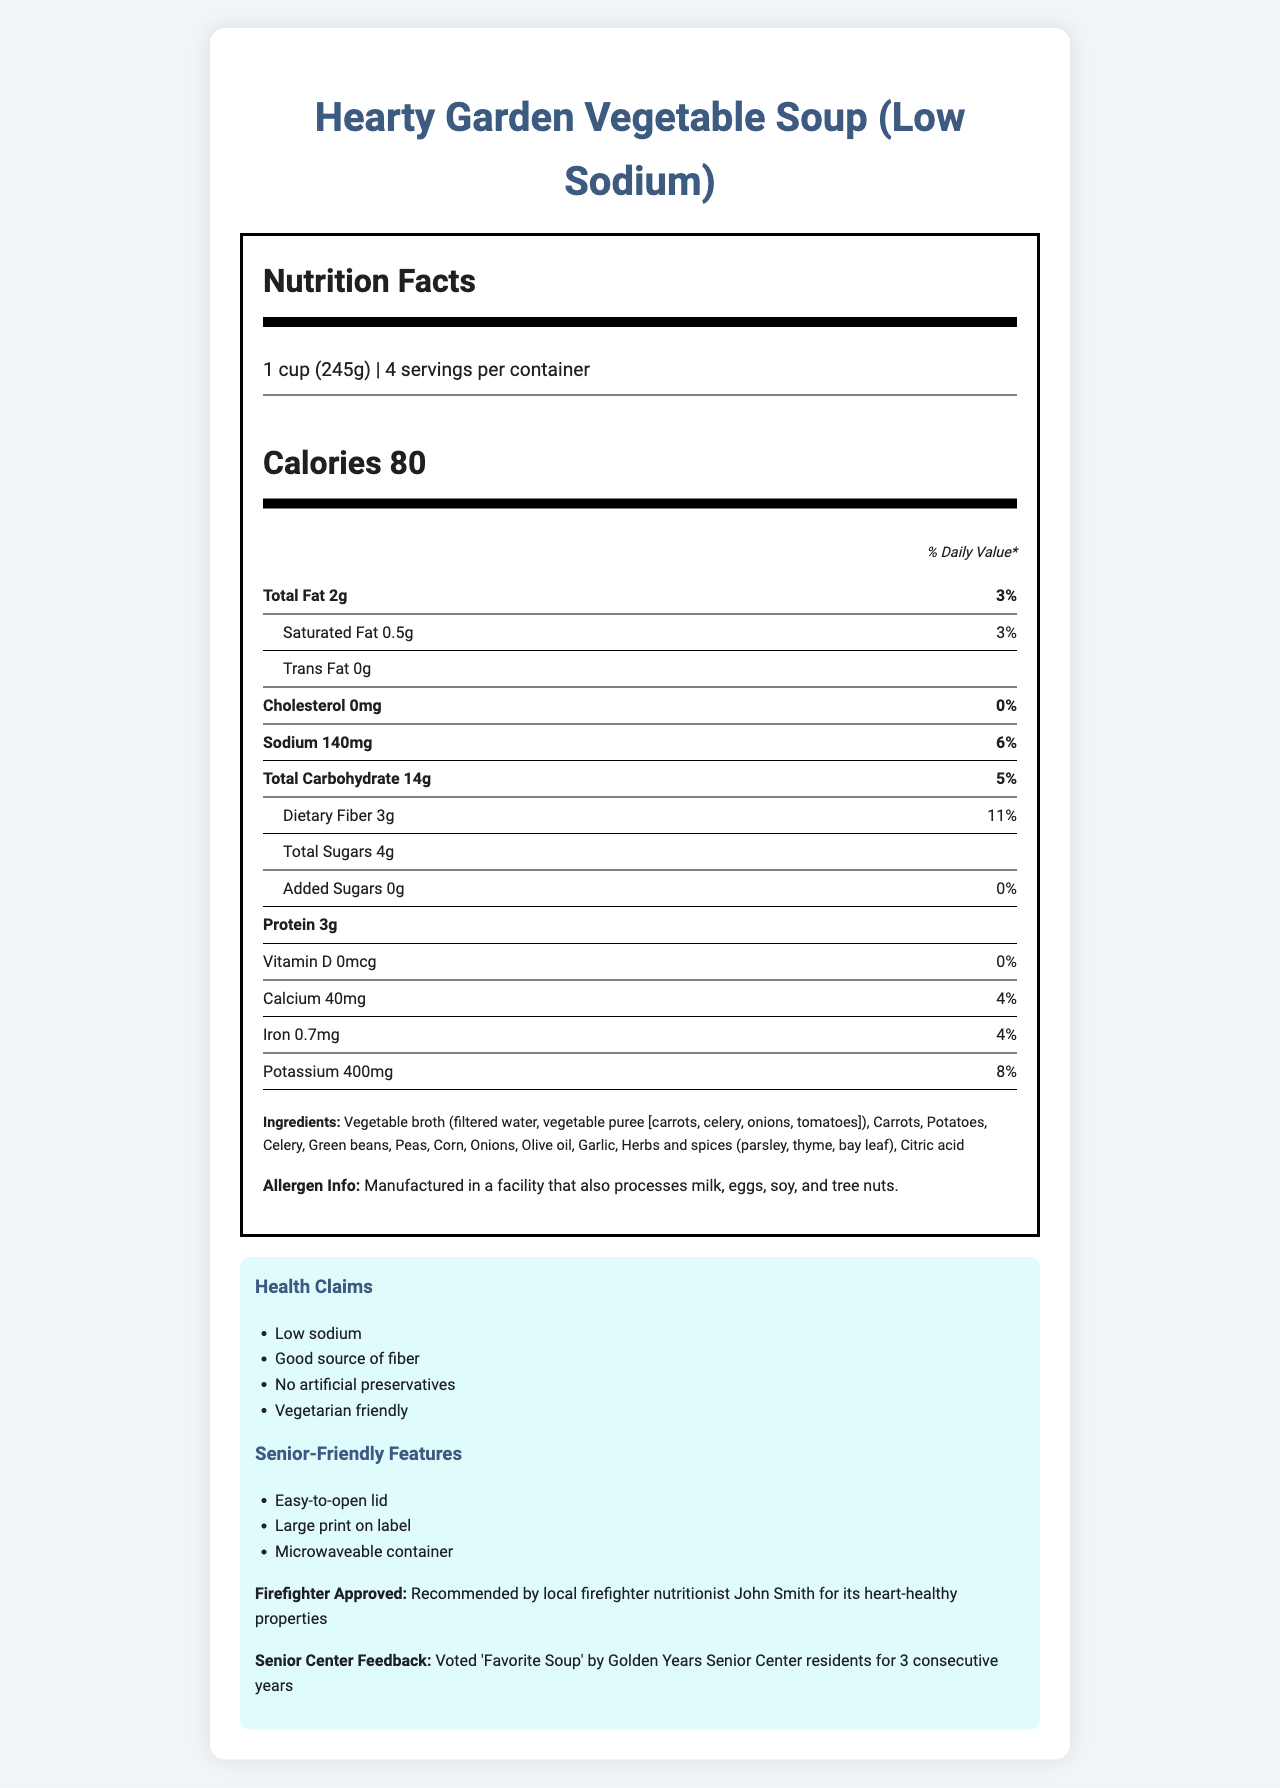what is the serving size? The serving size is explicitly mentioned as "1 cup (245g)" in the document.
Answer: 1 cup (245g) how many calories are in one serving? The calories per serving are listed as 80 in the document.
Answer: 80 calories how much dietary fiber does one serving contain? The document indicates that one serving contains 3g of dietary fiber.
Answer: 3g what is the total fat content per serving? The total fat content per serving is listed as 2g.
Answer: 2g what allergens might this soup contain? The allergen information mentions that the soup is manufactured in a facility that also processes milk, eggs, soy, and tree nuts.
Answer: Milk, eggs, soy, and tree nuts how many servings are there per container? The document states that there are 4 servings per container.
Answer: 4 how much sodium is in each serving of the soup? The sodium content per serving is listed as 140mg.
Answer: 140mg which of the following is NOT an ingredient in the soup? A. Carrots B. Celery C. Beef broth D. Olive oil The list of ingredients includes vegetarian options like vegetable broth, carrots, celery, and olive oil, but not beef broth.
Answer: C. Beef broth which nutrient has the highest daily value percentage? A. Sodium B. Dietary Fiber C. Total Fat D. Protein The nutrient with the highest daily value percentage is dietary fiber at 11%.
Answer: B. Dietary Fiber is this soup high in cholesterol? The cholesterol content is listed as 0mg, which is 0% of the daily value.
Answer: No summarize the key features and nutritional information of the soup. The summary covers the basic nutritional facts, health claims, and senior-friendly features, providing a comprehensive view of the document.
Answer: This is a low-sodium, vegetarian-friendly soup called Hearty Garden Vegetable Soup. It contains 80 calories per serving, with 2g of total fat, 14g of carbohydrates, 3g of dietary fiber, and 3g of protein. The soup is also high in various health benefits like being a good source of fiber, having no artificial preservatives, and having easy-to-open packaging and large print for seniors. It is also firefighter approved for its heart-healthy properties. what is the monthly sales for this soup? The document does not provide any data regarding the sales figures of the soup.
Answer: Not enough information who approved this soup for its heart-healthy properties? The document states that local firefighter nutritionist John Smith recommended the soup for its heart-healthy properties.
Answer: Firefighter nutritionist John Smith what is the total carbohydrate content per serving? The document lists the total carbohydrate content as 14g per serving.
Answer: 14g 